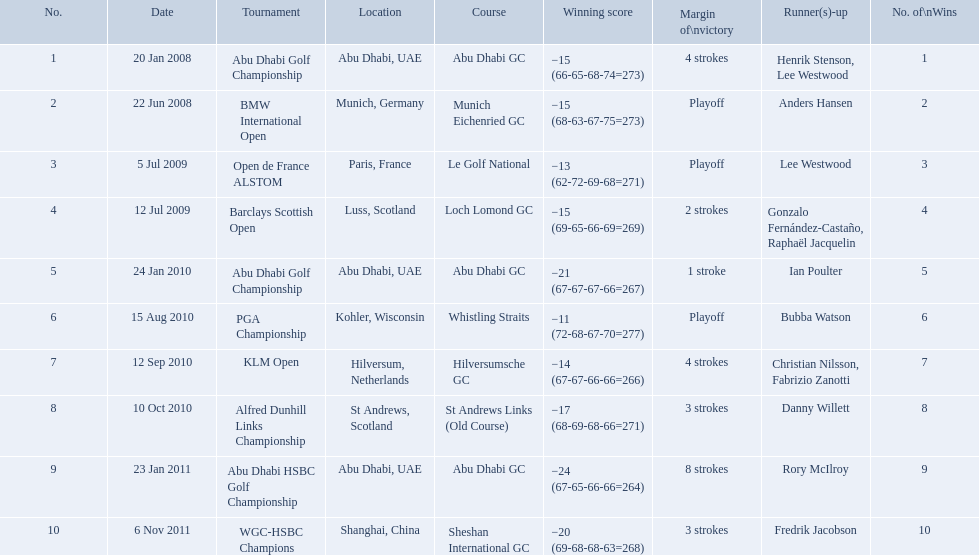Can you parse all the data within this table? {'header': ['No.', 'Date', 'Tournament', 'Location', 'Course', 'Winning score', 'Margin of\\nvictory', 'Runner(s)-up', 'No. of\\nWins'], 'rows': [['1', '20 Jan 2008', 'Abu Dhabi Golf Championship', 'Abu Dhabi, UAE', 'Abu Dhabi GC', '−15 (66-65-68-74=273)', '4 strokes', 'Henrik Stenson, Lee Westwood', '1'], ['2', '22 Jun 2008', 'BMW International Open', 'Munich, Germany', 'Munich Eichenried GC', '−15 (68-63-67-75=273)', 'Playoff', 'Anders Hansen', '2'], ['3', '5 Jul 2009', 'Open de France ALSTOM', 'Paris, France', 'Le Golf National', '−13 (62-72-69-68=271)', 'Playoff', 'Lee Westwood', '3'], ['4', '12 Jul 2009', 'Barclays Scottish Open', 'Luss, Scotland', 'Loch Lomond GC', '−15 (69-65-66-69=269)', '2 strokes', 'Gonzalo Fernández-Castaño, Raphaël Jacquelin', '4'], ['5', '24 Jan 2010', 'Abu Dhabi Golf Championship', 'Abu Dhabi, UAE', 'Abu Dhabi GC', '−21 (67-67-67-66=267)', '1 stroke', 'Ian Poulter', '5'], ['6', '15 Aug 2010', 'PGA Championship', 'Kohler, Wisconsin', 'Whistling Straits', '−11 (72-68-67-70=277)', 'Playoff', 'Bubba Watson', '6'], ['7', '12 Sep 2010', 'KLM Open', 'Hilversum, Netherlands', 'Hilversumsche GC', '−14 (67-67-66-66=266)', '4 strokes', 'Christian Nilsson, Fabrizio Zanotti', '7'], ['8', '10 Oct 2010', 'Alfred Dunhill Links Championship', 'St Andrews, Scotland', 'St Andrews Links (Old Course)', '−17 (68-69-68-66=271)', '3 strokes', 'Danny Willett', '8'], ['9', '23 Jan 2011', 'Abu Dhabi HSBC Golf Championship', 'Abu Dhabi, UAE', 'Abu Dhabi GC', '−24 (67-65-66-66=264)', '8 strokes', 'Rory McIlroy', '9'], ['10', '6 Nov 2011', 'WGC-HSBC Champions', 'Shanghai, China', 'Sheshan International GC', '−20 (69-68-68-63=268)', '3 strokes', 'Fredrik Jacobson', '10']]} What were the margins of victories of the tournaments? 4 strokes, Playoff, Playoff, 2 strokes, 1 stroke, Playoff, 4 strokes, 3 strokes, 8 strokes, 3 strokes. Of these, what was the margin of victory of the klm and the barklay 2 strokes, 4 strokes. What were the difference between these? 2 strokes. What were all of the tournaments martin played in? Abu Dhabi Golf Championship, BMW International Open, Open de France ALSTOM, Barclays Scottish Open, Abu Dhabi Golf Championship, PGA Championship, KLM Open, Alfred Dunhill Links Championship, Abu Dhabi HSBC Golf Championship, WGC-HSBC Champions. And how many strokes did he score? −15 (66-65-68-74=273), −15 (68-63-67-75=273), −13 (62-72-69-68=271), −15 (69-65-66-69=269), −21 (67-67-67-66=267), −11 (72-68-67-70=277), −14 (67-67-66-66=266), −17 (68-69-68-66=271), −24 (67-65-66-66=264), −20 (69-68-68-63=268). What about during barclays and klm? −15 (69-65-66-69=269), −14 (67-67-66-66=266). How many more were scored in klm? 2 strokes. 